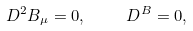Convert formula to latex. <formula><loc_0><loc_0><loc_500><loc_500>\ D ^ { 2 } B _ { \mu } = 0 , \quad \ D ^ { B } = 0 ,</formula> 